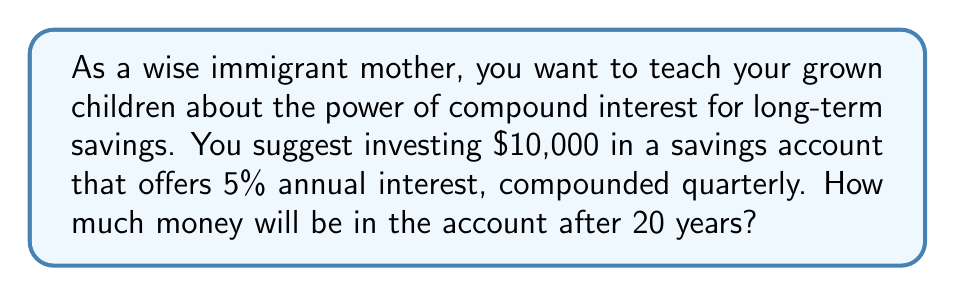What is the answer to this math problem? Let's approach this step-by-step using the compound interest formula:

$$A = P(1 + \frac{r}{n})^{nt}$$

Where:
$A$ = final amount
$P$ = principal (initial investment)
$r$ = annual interest rate (as a decimal)
$n$ = number of times interest is compounded per year
$t$ = number of years

Given:
$P = 10,000$
$r = 0.05$ (5% expressed as a decimal)
$n = 4$ (compounded quarterly, so 4 times per year)
$t = 20$ years

Let's substitute these values into the formula:

$$A = 10,000(1 + \frac{0.05}{4})^{4 * 20}$$

$$A = 10,000(1 + 0.0125)^{80}$$

$$A = 10,000(1.0125)^{80}$$

Using a calculator to evaluate this expression:

$$A = 10,000 * 2.7048 = 27,048$$

Therefore, after 20 years, the account will contain $27,048 (rounded to the nearest dollar).
Answer: $27,048 